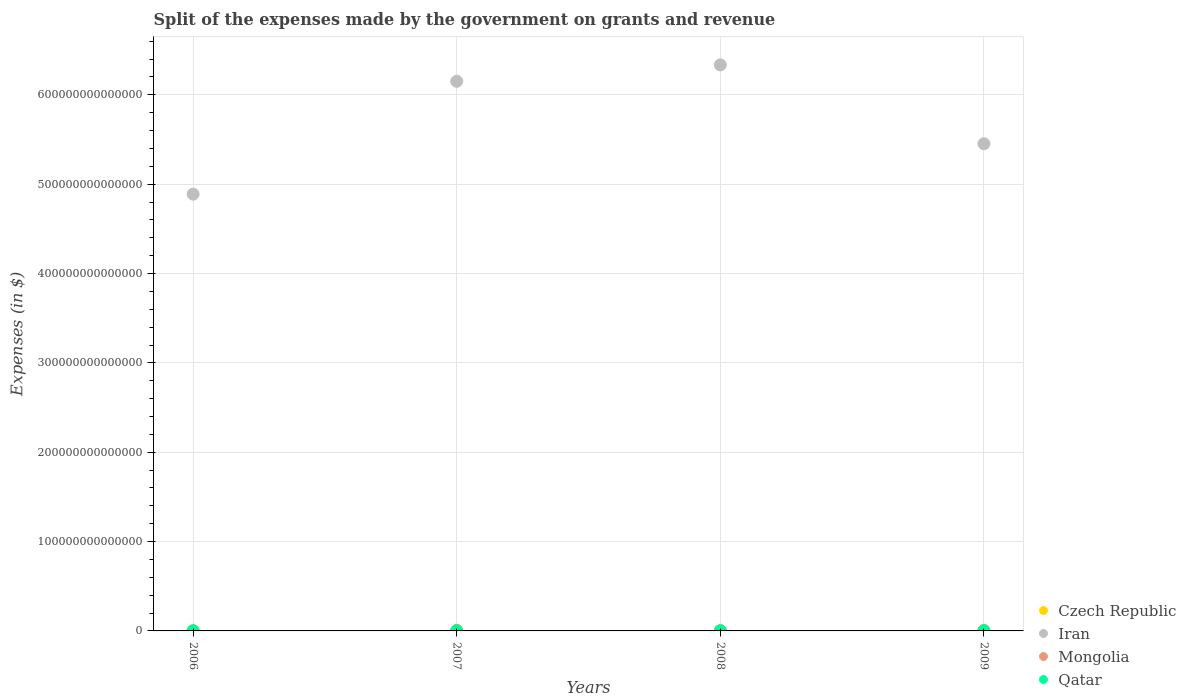What is the expenses made by the government on grants and revenue in Qatar in 2009?
Provide a succinct answer. 9.81e+1. Across all years, what is the maximum expenses made by the government on grants and revenue in Mongolia?
Offer a very short reply. 5.88e+11. Across all years, what is the minimum expenses made by the government on grants and revenue in Qatar?
Keep it short and to the point. 4.14e+1. In which year was the expenses made by the government on grants and revenue in Mongolia maximum?
Your answer should be very brief. 2007. In which year was the expenses made by the government on grants and revenue in Qatar minimum?
Ensure brevity in your answer.  2006. What is the total expenses made by the government on grants and revenue in Iran in the graph?
Give a very brief answer. 2.28e+15. What is the difference between the expenses made by the government on grants and revenue in Czech Republic in 2006 and that in 2009?
Your answer should be very brief. -5.62e+1. What is the difference between the expenses made by the government on grants and revenue in Czech Republic in 2006 and the expenses made by the government on grants and revenue in Qatar in 2007?
Offer a terse response. 2.45e+1. What is the average expenses made by the government on grants and revenue in Iran per year?
Provide a succinct answer. 5.71e+14. In the year 2006, what is the difference between the expenses made by the government on grants and revenue in Iran and expenses made by the government on grants and revenue in Qatar?
Your answer should be very brief. 4.89e+14. What is the ratio of the expenses made by the government on grants and revenue in Qatar in 2007 to that in 2008?
Provide a succinct answer. 0.78. Is the expenses made by the government on grants and revenue in Czech Republic in 2007 less than that in 2009?
Offer a very short reply. Yes. What is the difference between the highest and the second highest expenses made by the government on grants and revenue in Qatar?
Your answer should be compact. 2.42e+1. What is the difference between the highest and the lowest expenses made by the government on grants and revenue in Qatar?
Offer a very short reply. 5.68e+1. In how many years, is the expenses made by the government on grants and revenue in Iran greater than the average expenses made by the government on grants and revenue in Iran taken over all years?
Provide a succinct answer. 2. Is it the case that in every year, the sum of the expenses made by the government on grants and revenue in Iran and expenses made by the government on grants and revenue in Czech Republic  is greater than the sum of expenses made by the government on grants and revenue in Mongolia and expenses made by the government on grants and revenue in Qatar?
Offer a terse response. Yes. How many dotlines are there?
Your answer should be compact. 4. What is the difference between two consecutive major ticks on the Y-axis?
Provide a succinct answer. 1.00e+14. Does the graph contain any zero values?
Provide a succinct answer. No. What is the title of the graph?
Your answer should be compact. Split of the expenses made by the government on grants and revenue. What is the label or title of the X-axis?
Offer a terse response. Years. What is the label or title of the Y-axis?
Offer a very short reply. Expenses (in $). What is the Expenses (in $) in Czech Republic in 2006?
Provide a succinct answer. 8.23e+1. What is the Expenses (in $) of Iran in 2006?
Your answer should be compact. 4.89e+14. What is the Expenses (in $) in Mongolia in 2006?
Make the answer very short. 2.56e+11. What is the Expenses (in $) in Qatar in 2006?
Give a very brief answer. 4.14e+1. What is the Expenses (in $) of Czech Republic in 2007?
Keep it short and to the point. 9.68e+1. What is the Expenses (in $) of Iran in 2007?
Ensure brevity in your answer.  6.15e+14. What is the Expenses (in $) of Mongolia in 2007?
Offer a very short reply. 5.88e+11. What is the Expenses (in $) of Qatar in 2007?
Provide a succinct answer. 5.77e+1. What is the Expenses (in $) of Czech Republic in 2008?
Offer a terse response. 1.26e+11. What is the Expenses (in $) in Iran in 2008?
Offer a very short reply. 6.34e+14. What is the Expenses (in $) in Mongolia in 2008?
Give a very brief answer. 3.38e+11. What is the Expenses (in $) in Qatar in 2008?
Provide a succinct answer. 7.40e+1. What is the Expenses (in $) of Czech Republic in 2009?
Keep it short and to the point. 1.38e+11. What is the Expenses (in $) in Iran in 2009?
Keep it short and to the point. 5.45e+14. What is the Expenses (in $) of Mongolia in 2009?
Offer a very short reply. 4.95e+11. What is the Expenses (in $) in Qatar in 2009?
Offer a very short reply. 9.81e+1. Across all years, what is the maximum Expenses (in $) in Czech Republic?
Give a very brief answer. 1.38e+11. Across all years, what is the maximum Expenses (in $) of Iran?
Your answer should be very brief. 6.34e+14. Across all years, what is the maximum Expenses (in $) of Mongolia?
Keep it short and to the point. 5.88e+11. Across all years, what is the maximum Expenses (in $) of Qatar?
Your answer should be compact. 9.81e+1. Across all years, what is the minimum Expenses (in $) in Czech Republic?
Offer a very short reply. 8.23e+1. Across all years, what is the minimum Expenses (in $) of Iran?
Give a very brief answer. 4.89e+14. Across all years, what is the minimum Expenses (in $) of Mongolia?
Give a very brief answer. 2.56e+11. Across all years, what is the minimum Expenses (in $) of Qatar?
Make the answer very short. 4.14e+1. What is the total Expenses (in $) of Czech Republic in the graph?
Your answer should be very brief. 4.43e+11. What is the total Expenses (in $) in Iran in the graph?
Provide a succinct answer. 2.28e+15. What is the total Expenses (in $) of Mongolia in the graph?
Give a very brief answer. 1.68e+12. What is the total Expenses (in $) of Qatar in the graph?
Ensure brevity in your answer.  2.71e+11. What is the difference between the Expenses (in $) in Czech Republic in 2006 and that in 2007?
Make the answer very short. -1.45e+1. What is the difference between the Expenses (in $) in Iran in 2006 and that in 2007?
Your answer should be compact. -1.26e+14. What is the difference between the Expenses (in $) in Mongolia in 2006 and that in 2007?
Your answer should be compact. -3.31e+11. What is the difference between the Expenses (in $) of Qatar in 2006 and that in 2007?
Your response must be concise. -1.64e+1. What is the difference between the Expenses (in $) in Czech Republic in 2006 and that in 2008?
Provide a succinct answer. -4.33e+1. What is the difference between the Expenses (in $) in Iran in 2006 and that in 2008?
Your answer should be compact. -1.45e+14. What is the difference between the Expenses (in $) of Mongolia in 2006 and that in 2008?
Give a very brief answer. -8.18e+1. What is the difference between the Expenses (in $) of Qatar in 2006 and that in 2008?
Offer a very short reply. -3.26e+1. What is the difference between the Expenses (in $) of Czech Republic in 2006 and that in 2009?
Give a very brief answer. -5.62e+1. What is the difference between the Expenses (in $) of Iran in 2006 and that in 2009?
Offer a terse response. -5.64e+13. What is the difference between the Expenses (in $) in Mongolia in 2006 and that in 2009?
Give a very brief answer. -2.39e+11. What is the difference between the Expenses (in $) in Qatar in 2006 and that in 2009?
Your response must be concise. -5.68e+1. What is the difference between the Expenses (in $) in Czech Republic in 2007 and that in 2008?
Your response must be concise. -2.88e+1. What is the difference between the Expenses (in $) of Iran in 2007 and that in 2008?
Your answer should be very brief. -1.84e+13. What is the difference between the Expenses (in $) in Mongolia in 2007 and that in 2008?
Offer a terse response. 2.50e+11. What is the difference between the Expenses (in $) of Qatar in 2007 and that in 2008?
Ensure brevity in your answer.  -1.62e+1. What is the difference between the Expenses (in $) in Czech Republic in 2007 and that in 2009?
Provide a short and direct response. -4.17e+1. What is the difference between the Expenses (in $) in Iran in 2007 and that in 2009?
Give a very brief answer. 6.99e+13. What is the difference between the Expenses (in $) in Mongolia in 2007 and that in 2009?
Your answer should be very brief. 9.22e+1. What is the difference between the Expenses (in $) in Qatar in 2007 and that in 2009?
Give a very brief answer. -4.04e+1. What is the difference between the Expenses (in $) in Czech Republic in 2008 and that in 2009?
Offer a terse response. -1.29e+1. What is the difference between the Expenses (in $) in Iran in 2008 and that in 2009?
Give a very brief answer. 8.83e+13. What is the difference between the Expenses (in $) in Mongolia in 2008 and that in 2009?
Your answer should be very brief. -1.57e+11. What is the difference between the Expenses (in $) in Qatar in 2008 and that in 2009?
Offer a terse response. -2.42e+1. What is the difference between the Expenses (in $) in Czech Republic in 2006 and the Expenses (in $) in Iran in 2007?
Keep it short and to the point. -6.15e+14. What is the difference between the Expenses (in $) of Czech Republic in 2006 and the Expenses (in $) of Mongolia in 2007?
Give a very brief answer. -5.05e+11. What is the difference between the Expenses (in $) in Czech Republic in 2006 and the Expenses (in $) in Qatar in 2007?
Ensure brevity in your answer.  2.45e+1. What is the difference between the Expenses (in $) of Iran in 2006 and the Expenses (in $) of Mongolia in 2007?
Ensure brevity in your answer.  4.88e+14. What is the difference between the Expenses (in $) of Iran in 2006 and the Expenses (in $) of Qatar in 2007?
Ensure brevity in your answer.  4.89e+14. What is the difference between the Expenses (in $) of Mongolia in 2006 and the Expenses (in $) of Qatar in 2007?
Offer a very short reply. 1.99e+11. What is the difference between the Expenses (in $) of Czech Republic in 2006 and the Expenses (in $) of Iran in 2008?
Your answer should be very brief. -6.33e+14. What is the difference between the Expenses (in $) of Czech Republic in 2006 and the Expenses (in $) of Mongolia in 2008?
Offer a very short reply. -2.56e+11. What is the difference between the Expenses (in $) of Czech Republic in 2006 and the Expenses (in $) of Qatar in 2008?
Your answer should be very brief. 8.32e+09. What is the difference between the Expenses (in $) in Iran in 2006 and the Expenses (in $) in Mongolia in 2008?
Ensure brevity in your answer.  4.89e+14. What is the difference between the Expenses (in $) in Iran in 2006 and the Expenses (in $) in Qatar in 2008?
Offer a very short reply. 4.89e+14. What is the difference between the Expenses (in $) in Mongolia in 2006 and the Expenses (in $) in Qatar in 2008?
Your answer should be compact. 1.82e+11. What is the difference between the Expenses (in $) in Czech Republic in 2006 and the Expenses (in $) in Iran in 2009?
Offer a terse response. -5.45e+14. What is the difference between the Expenses (in $) of Czech Republic in 2006 and the Expenses (in $) of Mongolia in 2009?
Your response must be concise. -4.13e+11. What is the difference between the Expenses (in $) in Czech Republic in 2006 and the Expenses (in $) in Qatar in 2009?
Your answer should be very brief. -1.59e+1. What is the difference between the Expenses (in $) of Iran in 2006 and the Expenses (in $) of Mongolia in 2009?
Make the answer very short. 4.88e+14. What is the difference between the Expenses (in $) in Iran in 2006 and the Expenses (in $) in Qatar in 2009?
Provide a succinct answer. 4.89e+14. What is the difference between the Expenses (in $) of Mongolia in 2006 and the Expenses (in $) of Qatar in 2009?
Your response must be concise. 1.58e+11. What is the difference between the Expenses (in $) of Czech Republic in 2007 and the Expenses (in $) of Iran in 2008?
Keep it short and to the point. -6.33e+14. What is the difference between the Expenses (in $) in Czech Republic in 2007 and the Expenses (in $) in Mongolia in 2008?
Make the answer very short. -2.41e+11. What is the difference between the Expenses (in $) of Czech Republic in 2007 and the Expenses (in $) of Qatar in 2008?
Provide a short and direct response. 2.28e+1. What is the difference between the Expenses (in $) in Iran in 2007 and the Expenses (in $) in Mongolia in 2008?
Give a very brief answer. 6.15e+14. What is the difference between the Expenses (in $) of Iran in 2007 and the Expenses (in $) of Qatar in 2008?
Your answer should be compact. 6.15e+14. What is the difference between the Expenses (in $) in Mongolia in 2007 and the Expenses (in $) in Qatar in 2008?
Give a very brief answer. 5.14e+11. What is the difference between the Expenses (in $) in Czech Republic in 2007 and the Expenses (in $) in Iran in 2009?
Make the answer very short. -5.45e+14. What is the difference between the Expenses (in $) of Czech Republic in 2007 and the Expenses (in $) of Mongolia in 2009?
Give a very brief answer. -3.99e+11. What is the difference between the Expenses (in $) in Czech Republic in 2007 and the Expenses (in $) in Qatar in 2009?
Offer a terse response. -1.38e+09. What is the difference between the Expenses (in $) of Iran in 2007 and the Expenses (in $) of Mongolia in 2009?
Offer a very short reply. 6.15e+14. What is the difference between the Expenses (in $) of Iran in 2007 and the Expenses (in $) of Qatar in 2009?
Make the answer very short. 6.15e+14. What is the difference between the Expenses (in $) in Mongolia in 2007 and the Expenses (in $) in Qatar in 2009?
Offer a terse response. 4.89e+11. What is the difference between the Expenses (in $) in Czech Republic in 2008 and the Expenses (in $) in Iran in 2009?
Make the answer very short. -5.45e+14. What is the difference between the Expenses (in $) of Czech Republic in 2008 and the Expenses (in $) of Mongolia in 2009?
Offer a terse response. -3.70e+11. What is the difference between the Expenses (in $) of Czech Republic in 2008 and the Expenses (in $) of Qatar in 2009?
Offer a very short reply. 2.74e+1. What is the difference between the Expenses (in $) of Iran in 2008 and the Expenses (in $) of Mongolia in 2009?
Your response must be concise. 6.33e+14. What is the difference between the Expenses (in $) in Iran in 2008 and the Expenses (in $) in Qatar in 2009?
Make the answer very short. 6.33e+14. What is the difference between the Expenses (in $) in Mongolia in 2008 and the Expenses (in $) in Qatar in 2009?
Provide a short and direct response. 2.40e+11. What is the average Expenses (in $) in Czech Republic per year?
Give a very brief answer. 1.11e+11. What is the average Expenses (in $) of Iran per year?
Give a very brief answer. 5.71e+14. What is the average Expenses (in $) in Mongolia per year?
Make the answer very short. 4.19e+11. What is the average Expenses (in $) in Qatar per year?
Provide a short and direct response. 6.78e+1. In the year 2006, what is the difference between the Expenses (in $) in Czech Republic and Expenses (in $) in Iran?
Offer a very short reply. -4.89e+14. In the year 2006, what is the difference between the Expenses (in $) of Czech Republic and Expenses (in $) of Mongolia?
Offer a very short reply. -1.74e+11. In the year 2006, what is the difference between the Expenses (in $) of Czech Republic and Expenses (in $) of Qatar?
Provide a short and direct response. 4.09e+1. In the year 2006, what is the difference between the Expenses (in $) in Iran and Expenses (in $) in Mongolia?
Offer a terse response. 4.89e+14. In the year 2006, what is the difference between the Expenses (in $) in Iran and Expenses (in $) in Qatar?
Your answer should be compact. 4.89e+14. In the year 2006, what is the difference between the Expenses (in $) in Mongolia and Expenses (in $) in Qatar?
Offer a very short reply. 2.15e+11. In the year 2007, what is the difference between the Expenses (in $) of Czech Republic and Expenses (in $) of Iran?
Your answer should be compact. -6.15e+14. In the year 2007, what is the difference between the Expenses (in $) in Czech Republic and Expenses (in $) in Mongolia?
Provide a short and direct response. -4.91e+11. In the year 2007, what is the difference between the Expenses (in $) of Czech Republic and Expenses (in $) of Qatar?
Your response must be concise. 3.90e+1. In the year 2007, what is the difference between the Expenses (in $) of Iran and Expenses (in $) of Mongolia?
Make the answer very short. 6.15e+14. In the year 2007, what is the difference between the Expenses (in $) in Iran and Expenses (in $) in Qatar?
Offer a very short reply. 6.15e+14. In the year 2007, what is the difference between the Expenses (in $) of Mongolia and Expenses (in $) of Qatar?
Give a very brief answer. 5.30e+11. In the year 2008, what is the difference between the Expenses (in $) of Czech Republic and Expenses (in $) of Iran?
Your answer should be very brief. -6.33e+14. In the year 2008, what is the difference between the Expenses (in $) in Czech Republic and Expenses (in $) in Mongolia?
Offer a terse response. -2.12e+11. In the year 2008, what is the difference between the Expenses (in $) of Czech Republic and Expenses (in $) of Qatar?
Your answer should be compact. 5.16e+1. In the year 2008, what is the difference between the Expenses (in $) of Iran and Expenses (in $) of Mongolia?
Offer a terse response. 6.33e+14. In the year 2008, what is the difference between the Expenses (in $) of Iran and Expenses (in $) of Qatar?
Provide a short and direct response. 6.33e+14. In the year 2008, what is the difference between the Expenses (in $) of Mongolia and Expenses (in $) of Qatar?
Offer a very short reply. 2.64e+11. In the year 2009, what is the difference between the Expenses (in $) in Czech Republic and Expenses (in $) in Iran?
Offer a very short reply. -5.45e+14. In the year 2009, what is the difference between the Expenses (in $) of Czech Republic and Expenses (in $) of Mongolia?
Offer a very short reply. -3.57e+11. In the year 2009, what is the difference between the Expenses (in $) of Czech Republic and Expenses (in $) of Qatar?
Your answer should be very brief. 4.03e+1. In the year 2009, what is the difference between the Expenses (in $) in Iran and Expenses (in $) in Mongolia?
Keep it short and to the point. 5.45e+14. In the year 2009, what is the difference between the Expenses (in $) in Iran and Expenses (in $) in Qatar?
Your response must be concise. 5.45e+14. In the year 2009, what is the difference between the Expenses (in $) of Mongolia and Expenses (in $) of Qatar?
Make the answer very short. 3.97e+11. What is the ratio of the Expenses (in $) in Czech Republic in 2006 to that in 2007?
Offer a terse response. 0.85. What is the ratio of the Expenses (in $) of Iran in 2006 to that in 2007?
Provide a short and direct response. 0.79. What is the ratio of the Expenses (in $) in Mongolia in 2006 to that in 2007?
Make the answer very short. 0.44. What is the ratio of the Expenses (in $) of Qatar in 2006 to that in 2007?
Your answer should be very brief. 0.72. What is the ratio of the Expenses (in $) of Czech Republic in 2006 to that in 2008?
Keep it short and to the point. 0.66. What is the ratio of the Expenses (in $) of Iran in 2006 to that in 2008?
Your answer should be very brief. 0.77. What is the ratio of the Expenses (in $) of Mongolia in 2006 to that in 2008?
Make the answer very short. 0.76. What is the ratio of the Expenses (in $) in Qatar in 2006 to that in 2008?
Provide a succinct answer. 0.56. What is the ratio of the Expenses (in $) of Czech Republic in 2006 to that in 2009?
Keep it short and to the point. 0.59. What is the ratio of the Expenses (in $) in Iran in 2006 to that in 2009?
Your answer should be compact. 0.9. What is the ratio of the Expenses (in $) in Mongolia in 2006 to that in 2009?
Give a very brief answer. 0.52. What is the ratio of the Expenses (in $) in Qatar in 2006 to that in 2009?
Offer a terse response. 0.42. What is the ratio of the Expenses (in $) in Czech Republic in 2007 to that in 2008?
Offer a terse response. 0.77. What is the ratio of the Expenses (in $) of Mongolia in 2007 to that in 2008?
Your answer should be compact. 1.74. What is the ratio of the Expenses (in $) of Qatar in 2007 to that in 2008?
Make the answer very short. 0.78. What is the ratio of the Expenses (in $) of Czech Republic in 2007 to that in 2009?
Keep it short and to the point. 0.7. What is the ratio of the Expenses (in $) in Iran in 2007 to that in 2009?
Give a very brief answer. 1.13. What is the ratio of the Expenses (in $) in Mongolia in 2007 to that in 2009?
Give a very brief answer. 1.19. What is the ratio of the Expenses (in $) in Qatar in 2007 to that in 2009?
Your response must be concise. 0.59. What is the ratio of the Expenses (in $) of Czech Republic in 2008 to that in 2009?
Ensure brevity in your answer.  0.91. What is the ratio of the Expenses (in $) of Iran in 2008 to that in 2009?
Your response must be concise. 1.16. What is the ratio of the Expenses (in $) in Mongolia in 2008 to that in 2009?
Offer a terse response. 0.68. What is the ratio of the Expenses (in $) of Qatar in 2008 to that in 2009?
Offer a very short reply. 0.75. What is the difference between the highest and the second highest Expenses (in $) in Czech Republic?
Offer a terse response. 1.29e+1. What is the difference between the highest and the second highest Expenses (in $) of Iran?
Give a very brief answer. 1.84e+13. What is the difference between the highest and the second highest Expenses (in $) in Mongolia?
Your response must be concise. 9.22e+1. What is the difference between the highest and the second highest Expenses (in $) of Qatar?
Offer a very short reply. 2.42e+1. What is the difference between the highest and the lowest Expenses (in $) of Czech Republic?
Your answer should be compact. 5.62e+1. What is the difference between the highest and the lowest Expenses (in $) of Iran?
Offer a very short reply. 1.45e+14. What is the difference between the highest and the lowest Expenses (in $) in Mongolia?
Give a very brief answer. 3.31e+11. What is the difference between the highest and the lowest Expenses (in $) in Qatar?
Provide a succinct answer. 5.68e+1. 